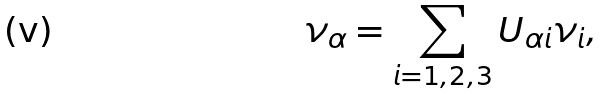<formula> <loc_0><loc_0><loc_500><loc_500>\nu _ { \alpha } = \sum _ { i = 1 , 2 , 3 } U _ { \alpha i } \nu _ { i } ,</formula> 